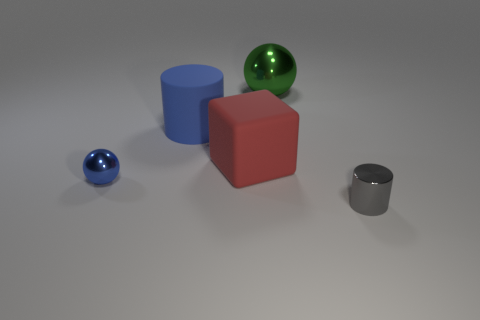Add 2 tiny cyan rubber things. How many objects exist? 7 Subtract all blocks. How many objects are left? 4 Add 1 green balls. How many green balls are left? 2 Add 1 tiny purple metallic things. How many tiny purple metallic things exist? 1 Subtract 0 yellow cylinders. How many objects are left? 5 Subtract all large blue rubber things. Subtract all tiny gray metal cylinders. How many objects are left? 3 